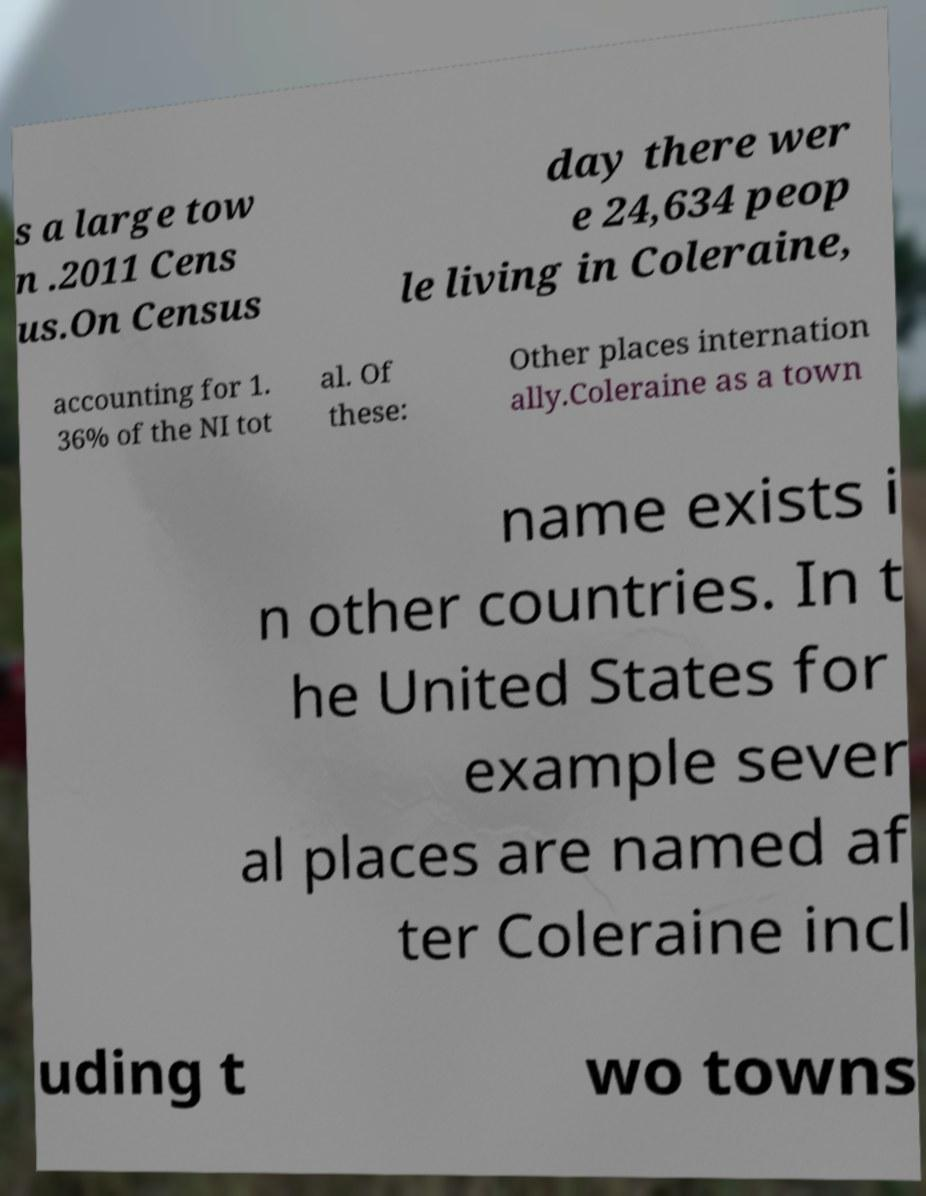Could you assist in decoding the text presented in this image and type it out clearly? s a large tow n .2011 Cens us.On Census day there wer e 24,634 peop le living in Coleraine, accounting for 1. 36% of the NI tot al. Of these: Other places internation ally.Coleraine as a town name exists i n other countries. In t he United States for example sever al places are named af ter Coleraine incl uding t wo towns 